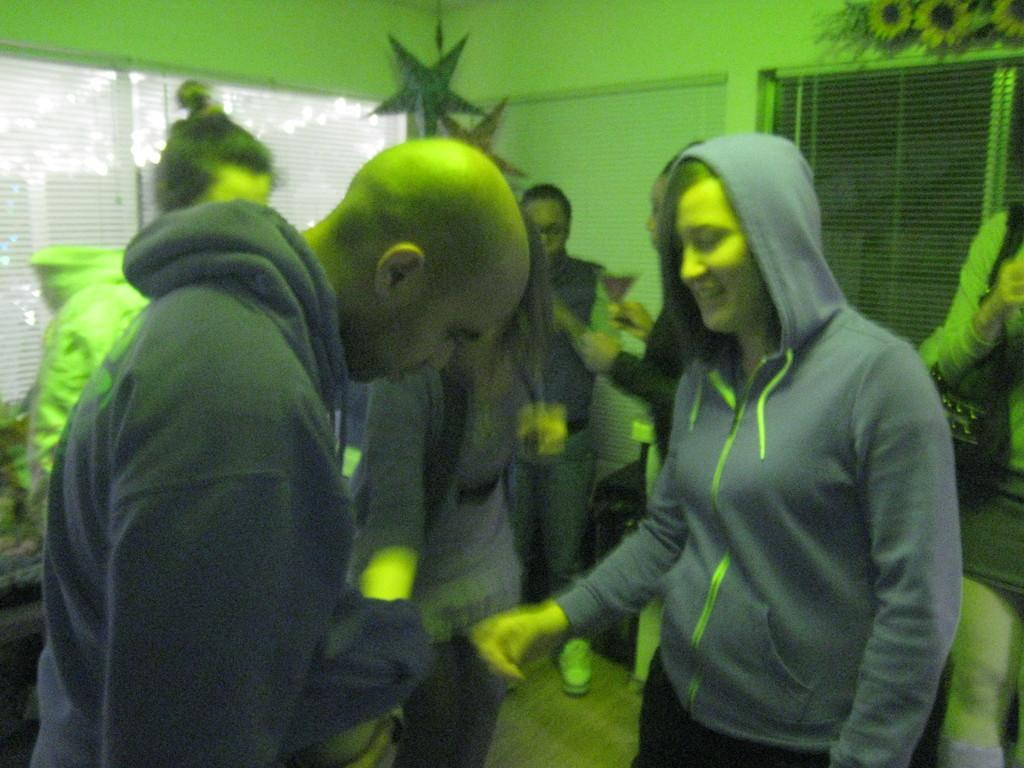What can be observed about the people in the image? There are people inside the room. What feature of the room allows for natural light and a view of the outdoors? There are windows in the room. What is visible in the sky in the image? Stars are visible in the image. What type of decorative or natural elements can be seen in the image? Flowers are present in the image. What object is being held by one of the people in the image? One person is holding a glass. What type of growth can be seen on the tray in the image? There is no tray present in the image, so no growth can be observed on it. 